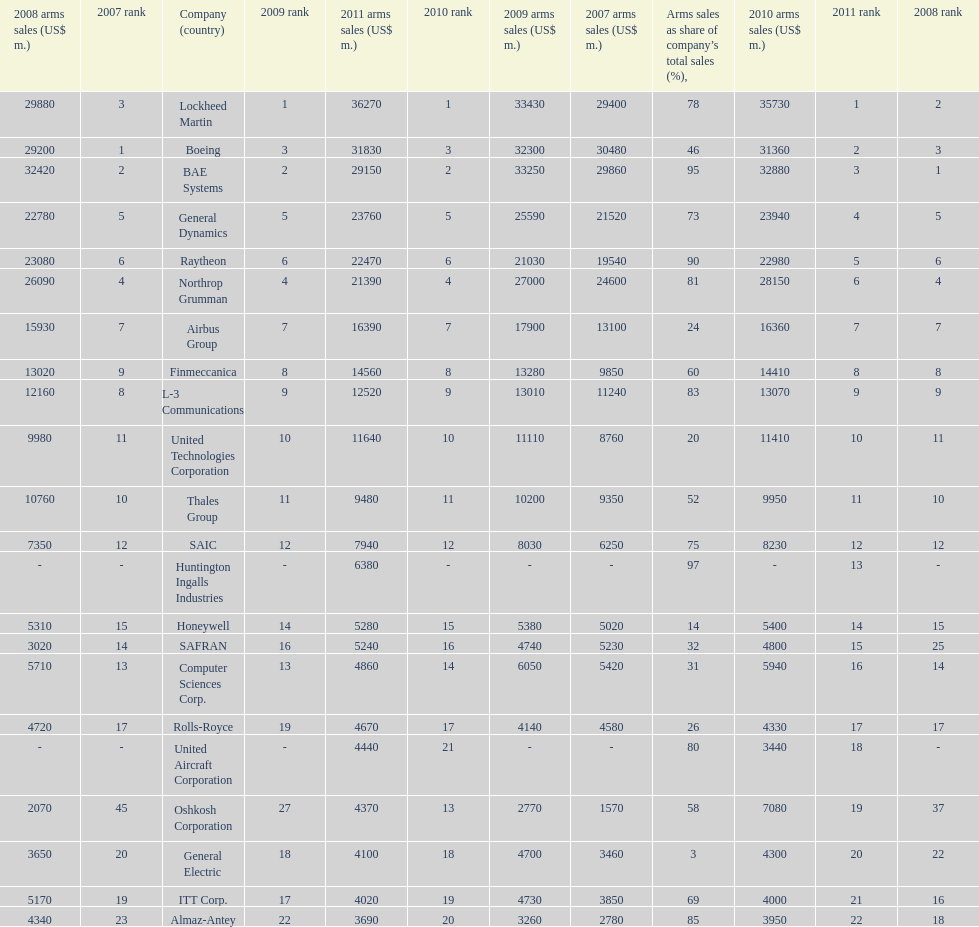How many companies are under the united states? 14. 